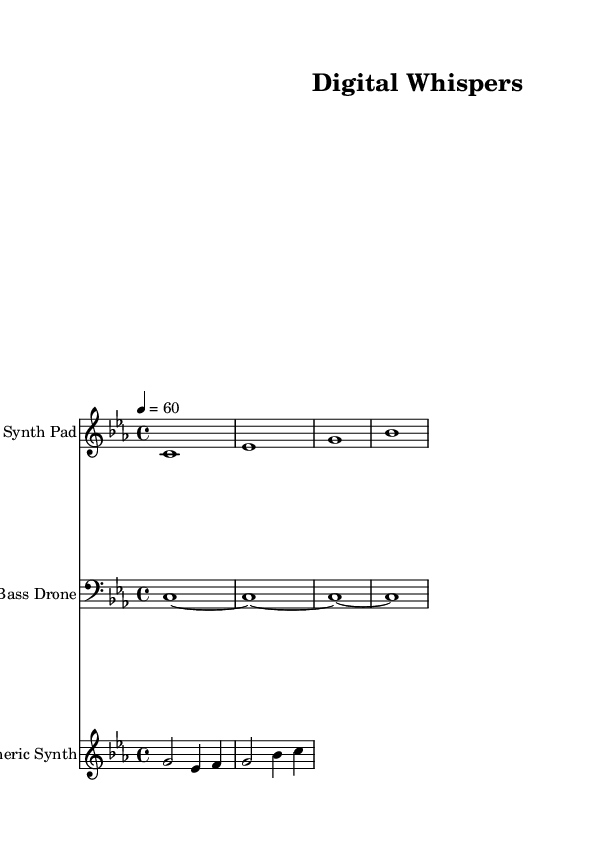What is the key signature of this music? The key signature is indicated at the beginning of the staff, showing that there are three flats. This corresponds to C minor.
Answer: C minor What is the time signature of this music? The time signature is found at the beginning of the score, shown as a "4/4" which indicates four beats per measure.
Answer: 4/4 What is the tempo marking in this sheet music? The tempo marking is indicated in beats per minute at the beginning, showing "4 = 60," which means there are 60 beats per minute in quarter notes.
Answer: 60 How many staves are present in this score? The score contains three distinct staves, one for each instrument: Synth Pad, Bass Drone, and Atmospheric Synth.
Answer: Three Which instrument has the highest pitch range? By comparing the melodic lines on the staves, the Atmospheric Synth line contains notes that are higher in pitch, specifically starting from G2 up to C.
Answer: Atmospheric Synth What is the rhythmic value of the first note in the Synth Pad line? The first note in the Synth Pad line is a whole note, as it is represented by a single note with no additional markings that would indicate shorter values.
Answer: Whole note What type of electronic music is represented by this sheet music? This music displays characteristics of ambient electronic soundscapes, using sustained tones and lush harmonies, typical for creating atmospheric soundscapes meant for focus.
Answer: Ambient electronic 